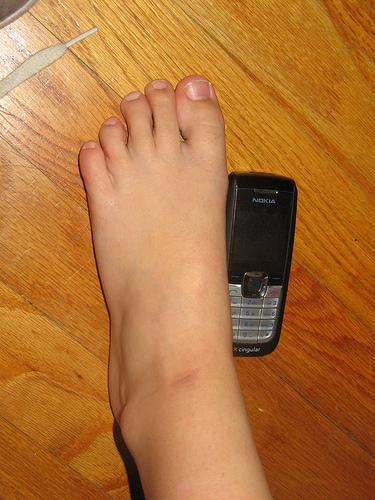Question: what body part is in the picture?
Choices:
A. Arm.
B. Leg.
C. Foot.
D. Head.
Answer with the letter. Answer: C Question: what is in the top left corner of the picture?
Choices:
A. Pencil.
B. Finger.
C. Shoelace.
D. String.
Answer with the letter. Answer: C Question: when was this picture taken?
Choices:
A. During the day.
B. At night.
C. In the afternoon.
D. In the morning.
Answer with the letter. Answer: A 